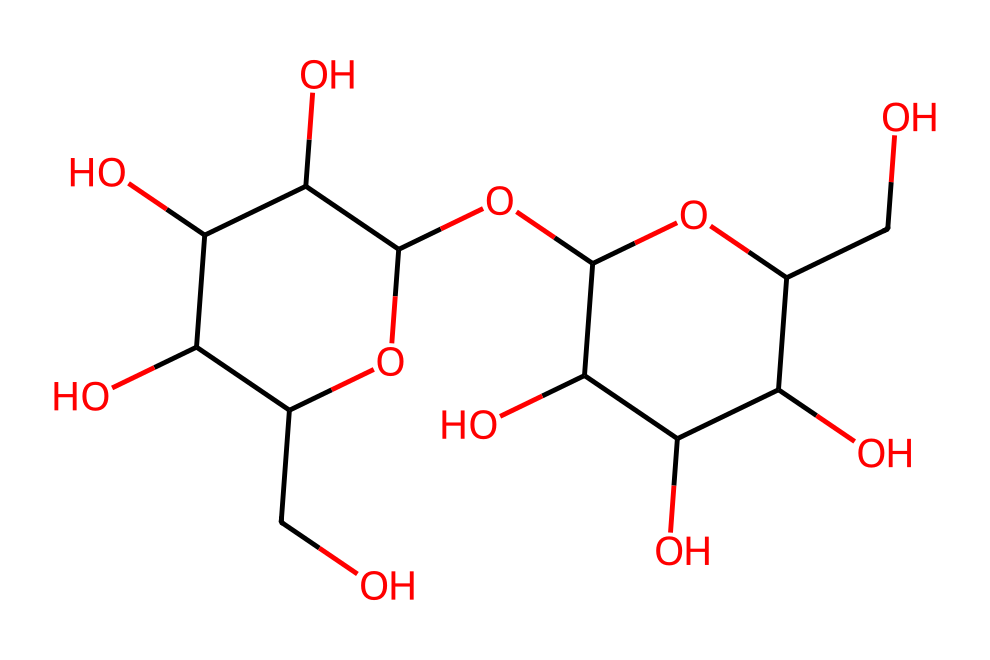What type of molecule is glycogen? The structure represents glycogen, which is characterized by its multiple glucose units linked together, indicating it is a polysaccharide.
Answer: polysaccharide How many glucose units are present in this glycogen molecule? By analyzing the structure, I can identify that the main chain and branching points are composed of multiple glucose rings. There are eight glucose units evident in the structure.
Answer: eight What is the primary function of glycogen in animals? Glycogen is primarily used for energy storage in animals. This is due to its branched structure, which allows for rapid mobilization of glucose when energy is needed.
Answer: energy storage Which linkage type connects the glucose units in glycogen? The glucose units in glycogen are primarily connected by alpha-1,4-glycosidic bonds along the chain and alpha-1,6-glycosidic bonds at the branching points. This specific type of linkage contributes to glycogen's structural properties.
Answer: alpha-1,4 and alpha-1,6 How does the structure of glycogen aid in its function? The highly branched structure of glycogen allows for rapid access to glucose molecules when energy is required, facilitating quick release during metabolic demands. This structural characteristic supports its role as an energy reservoir.
Answer: rapid access 